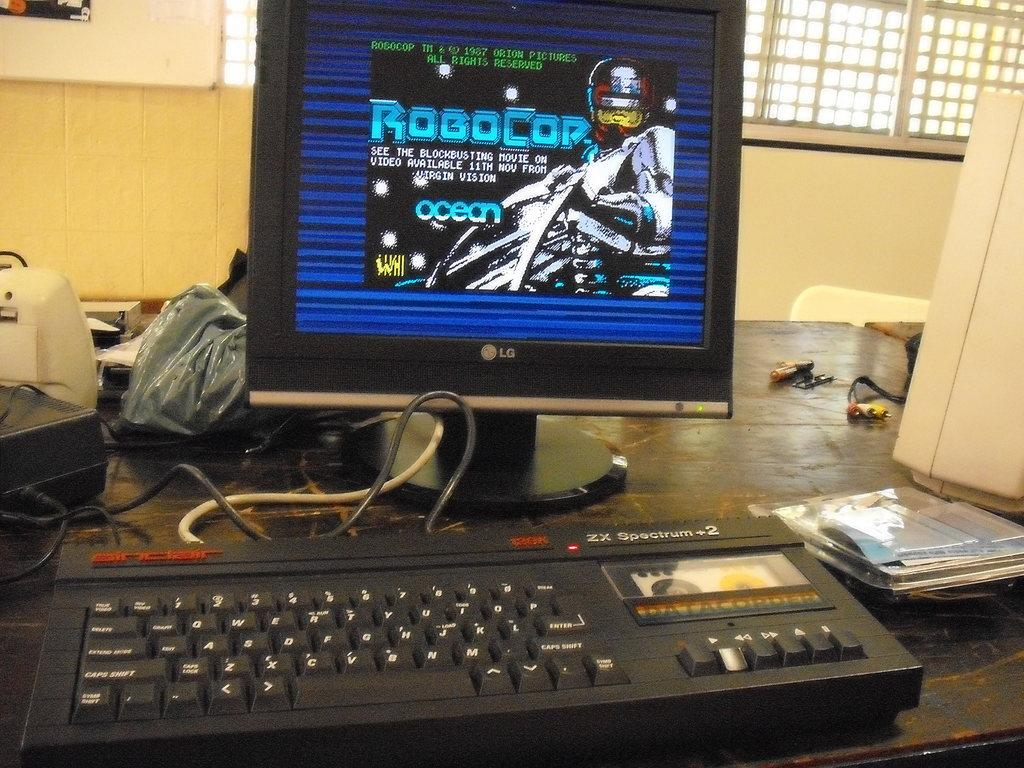<image>
Relay a brief, clear account of the picture shown. LG computer monitor showing a video game for RoboCop. 